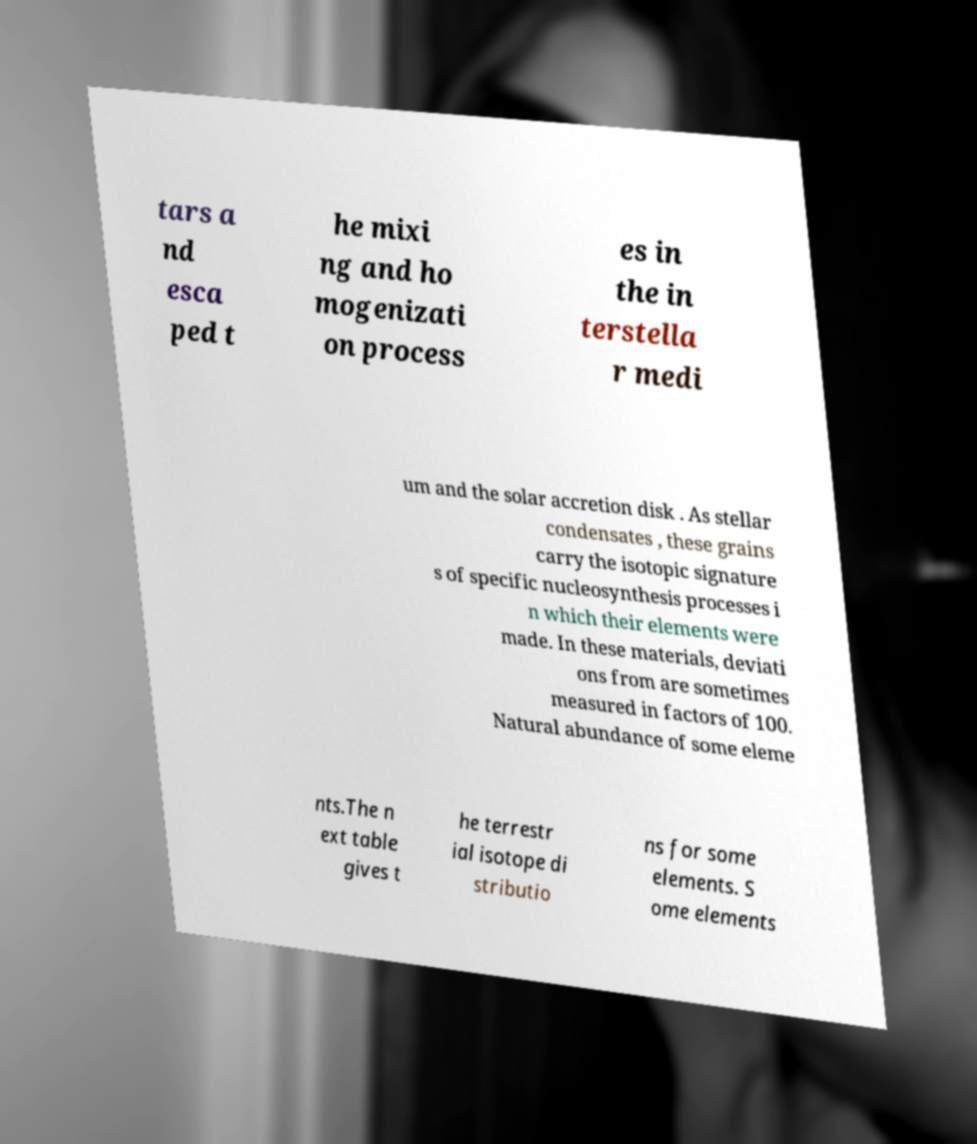Could you extract and type out the text from this image? tars a nd esca ped t he mixi ng and ho mogenizati on process es in the in terstella r medi um and the solar accretion disk . As stellar condensates , these grains carry the isotopic signature s of specific nucleosynthesis processes i n which their elements were made. In these materials, deviati ons from are sometimes measured in factors of 100. Natural abundance of some eleme nts.The n ext table gives t he terrestr ial isotope di stributio ns for some elements. S ome elements 